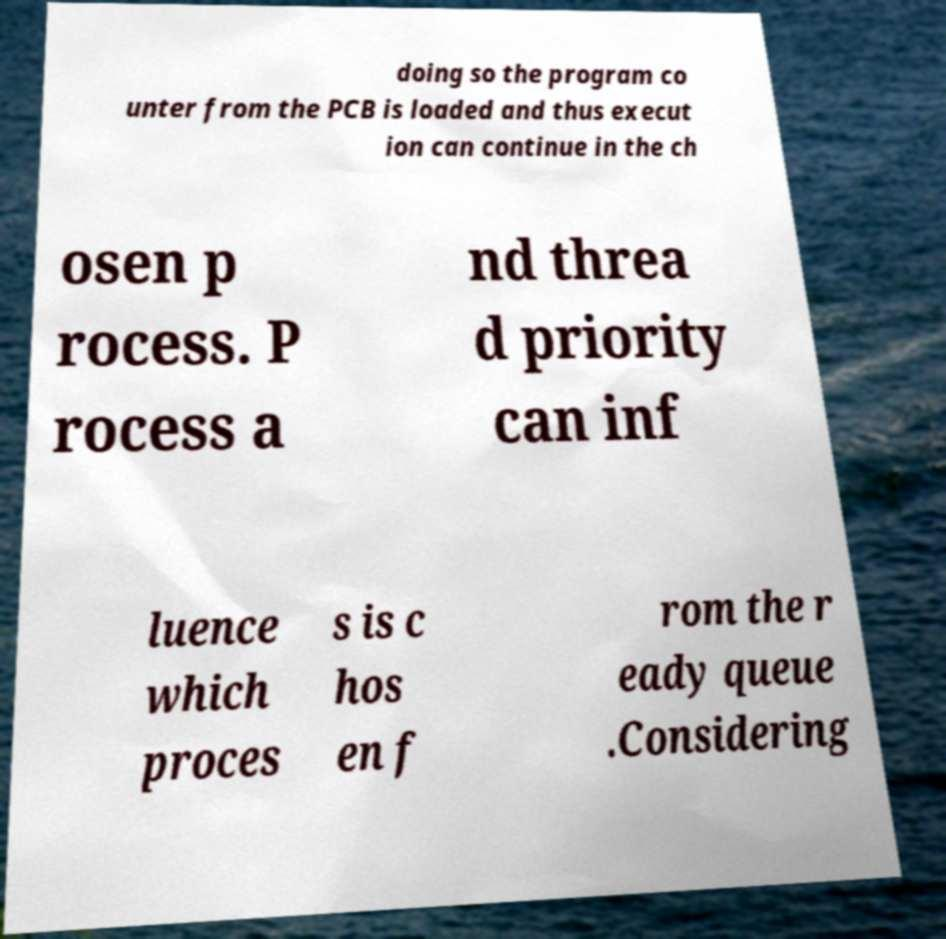Please identify and transcribe the text found in this image. doing so the program co unter from the PCB is loaded and thus execut ion can continue in the ch osen p rocess. P rocess a nd threa d priority can inf luence which proces s is c hos en f rom the r eady queue .Considering 